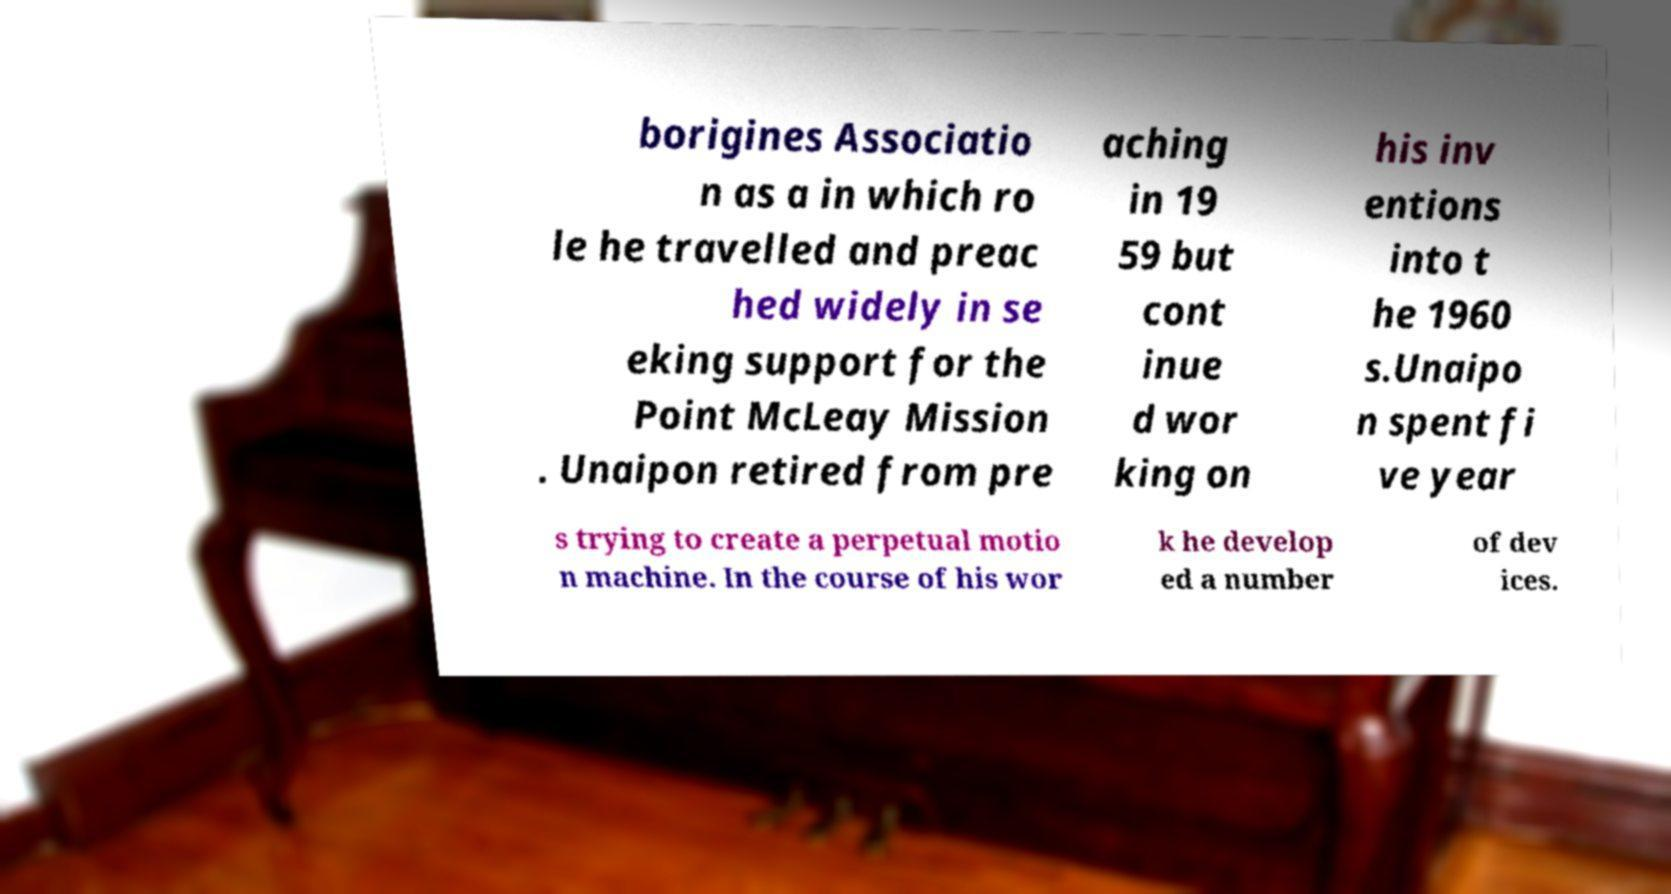For documentation purposes, I need the text within this image transcribed. Could you provide that? borigines Associatio n as a in which ro le he travelled and preac hed widely in se eking support for the Point McLeay Mission . Unaipon retired from pre aching in 19 59 but cont inue d wor king on his inv entions into t he 1960 s.Unaipo n spent fi ve year s trying to create a perpetual motio n machine. In the course of his wor k he develop ed a number of dev ices. 